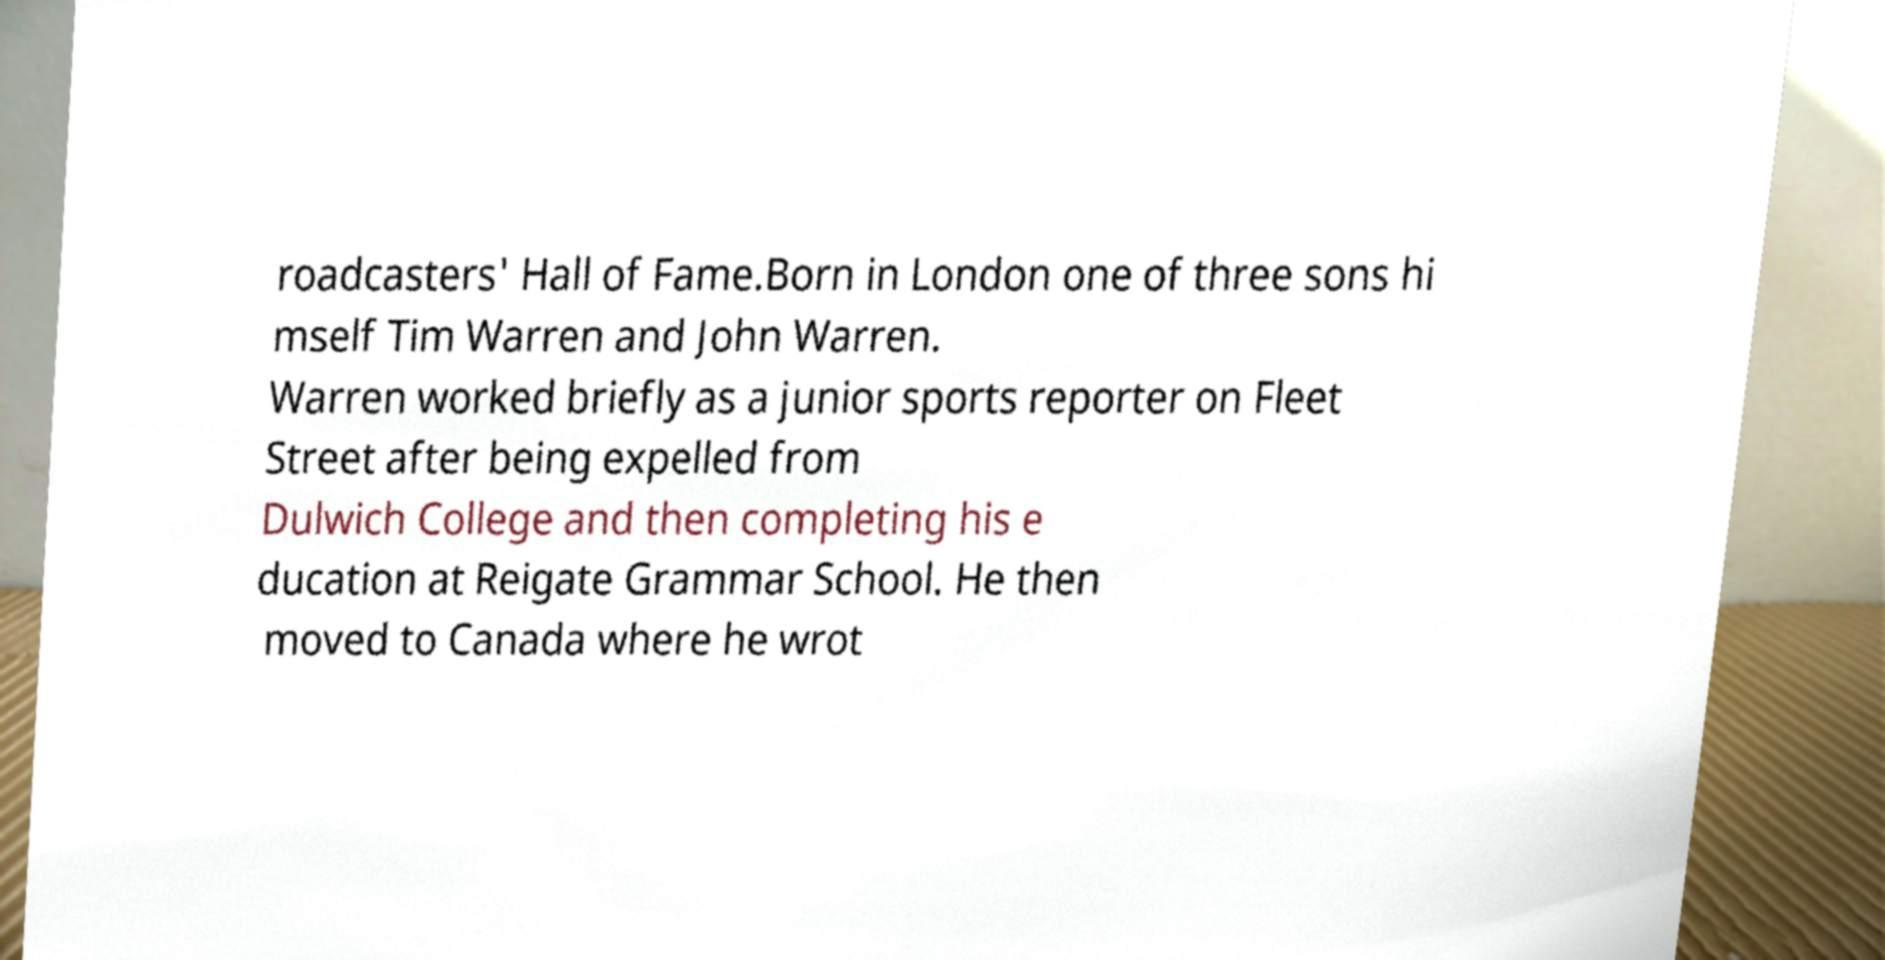Please identify and transcribe the text found in this image. roadcasters' Hall of Fame.Born in London one of three sons hi mself Tim Warren and John Warren. Warren worked briefly as a junior sports reporter on Fleet Street after being expelled from Dulwich College and then completing his e ducation at Reigate Grammar School. He then moved to Canada where he wrot 